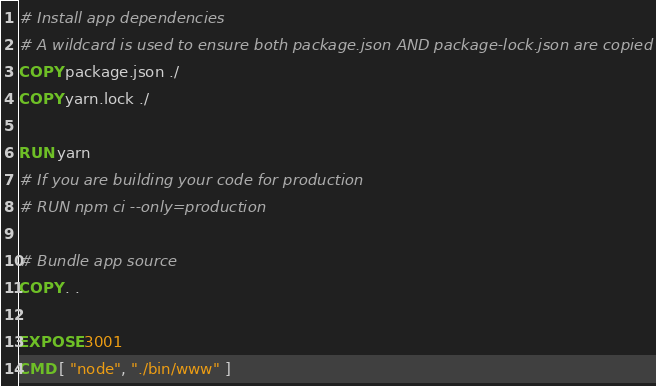<code> <loc_0><loc_0><loc_500><loc_500><_Dockerfile_># Install app dependencies
# A wildcard is used to ensure both package.json AND package-lock.json are copied
COPY package.json ./
COPY yarn.lock ./

RUN yarn
# If you are building your code for production
# RUN npm ci --only=production

# Bundle app source
COPY . .

EXPOSE 3001
CMD [ "node", "./bin/www" ]
</code> 